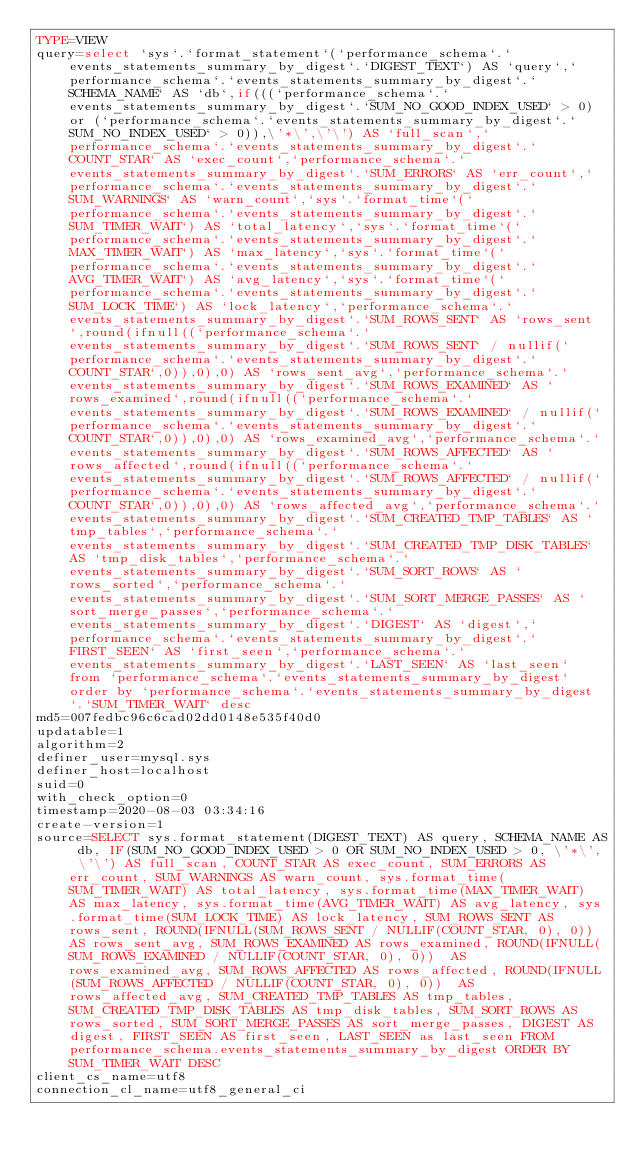<code> <loc_0><loc_0><loc_500><loc_500><_VisualBasic_>TYPE=VIEW
query=select `sys`.`format_statement`(`performance_schema`.`events_statements_summary_by_digest`.`DIGEST_TEXT`) AS `query`,`performance_schema`.`events_statements_summary_by_digest`.`SCHEMA_NAME` AS `db`,if(((`performance_schema`.`events_statements_summary_by_digest`.`SUM_NO_GOOD_INDEX_USED` > 0) or (`performance_schema`.`events_statements_summary_by_digest`.`SUM_NO_INDEX_USED` > 0)),\'*\',\'\') AS `full_scan`,`performance_schema`.`events_statements_summary_by_digest`.`COUNT_STAR` AS `exec_count`,`performance_schema`.`events_statements_summary_by_digest`.`SUM_ERRORS` AS `err_count`,`performance_schema`.`events_statements_summary_by_digest`.`SUM_WARNINGS` AS `warn_count`,`sys`.`format_time`(`performance_schema`.`events_statements_summary_by_digest`.`SUM_TIMER_WAIT`) AS `total_latency`,`sys`.`format_time`(`performance_schema`.`events_statements_summary_by_digest`.`MAX_TIMER_WAIT`) AS `max_latency`,`sys`.`format_time`(`performance_schema`.`events_statements_summary_by_digest`.`AVG_TIMER_WAIT`) AS `avg_latency`,`sys`.`format_time`(`performance_schema`.`events_statements_summary_by_digest`.`SUM_LOCK_TIME`) AS `lock_latency`,`performance_schema`.`events_statements_summary_by_digest`.`SUM_ROWS_SENT` AS `rows_sent`,round(ifnull((`performance_schema`.`events_statements_summary_by_digest`.`SUM_ROWS_SENT` / nullif(`performance_schema`.`events_statements_summary_by_digest`.`COUNT_STAR`,0)),0),0) AS `rows_sent_avg`,`performance_schema`.`events_statements_summary_by_digest`.`SUM_ROWS_EXAMINED` AS `rows_examined`,round(ifnull((`performance_schema`.`events_statements_summary_by_digest`.`SUM_ROWS_EXAMINED` / nullif(`performance_schema`.`events_statements_summary_by_digest`.`COUNT_STAR`,0)),0),0) AS `rows_examined_avg`,`performance_schema`.`events_statements_summary_by_digest`.`SUM_ROWS_AFFECTED` AS `rows_affected`,round(ifnull((`performance_schema`.`events_statements_summary_by_digest`.`SUM_ROWS_AFFECTED` / nullif(`performance_schema`.`events_statements_summary_by_digest`.`COUNT_STAR`,0)),0),0) AS `rows_affected_avg`,`performance_schema`.`events_statements_summary_by_digest`.`SUM_CREATED_TMP_TABLES` AS `tmp_tables`,`performance_schema`.`events_statements_summary_by_digest`.`SUM_CREATED_TMP_DISK_TABLES` AS `tmp_disk_tables`,`performance_schema`.`events_statements_summary_by_digest`.`SUM_SORT_ROWS` AS `rows_sorted`,`performance_schema`.`events_statements_summary_by_digest`.`SUM_SORT_MERGE_PASSES` AS `sort_merge_passes`,`performance_schema`.`events_statements_summary_by_digest`.`DIGEST` AS `digest`,`performance_schema`.`events_statements_summary_by_digest`.`FIRST_SEEN` AS `first_seen`,`performance_schema`.`events_statements_summary_by_digest`.`LAST_SEEN` AS `last_seen` from `performance_schema`.`events_statements_summary_by_digest` order by `performance_schema`.`events_statements_summary_by_digest`.`SUM_TIMER_WAIT` desc
md5=007fedbc96c6cad02dd0148e535f40d0
updatable=1
algorithm=2
definer_user=mysql.sys
definer_host=localhost
suid=0
with_check_option=0
timestamp=2020-08-03 03:34:16
create-version=1
source=SELECT sys.format_statement(DIGEST_TEXT) AS query, SCHEMA_NAME AS db, IF(SUM_NO_GOOD_INDEX_USED > 0 OR SUM_NO_INDEX_USED > 0, \'*\', \'\') AS full_scan, COUNT_STAR AS exec_count, SUM_ERRORS AS err_count, SUM_WARNINGS AS warn_count, sys.format_time(SUM_TIMER_WAIT) AS total_latency, sys.format_time(MAX_TIMER_WAIT) AS max_latency, sys.format_time(AVG_TIMER_WAIT) AS avg_latency, sys.format_time(SUM_LOCK_TIME) AS lock_latency, SUM_ROWS_SENT AS rows_sent, ROUND(IFNULL(SUM_ROWS_SENT / NULLIF(COUNT_STAR, 0), 0)) AS rows_sent_avg, SUM_ROWS_EXAMINED AS rows_examined, ROUND(IFNULL(SUM_ROWS_EXAMINED / NULLIF(COUNT_STAR, 0), 0))  AS rows_examined_avg, SUM_ROWS_AFFECTED AS rows_affected, ROUND(IFNULL(SUM_ROWS_AFFECTED / NULLIF(COUNT_STAR, 0), 0))  AS rows_affected_avg, SUM_CREATED_TMP_TABLES AS tmp_tables, SUM_CREATED_TMP_DISK_TABLES AS tmp_disk_tables, SUM_SORT_ROWS AS rows_sorted, SUM_SORT_MERGE_PASSES AS sort_merge_passes, DIGEST AS digest, FIRST_SEEN AS first_seen, LAST_SEEN as last_seen FROM performance_schema.events_statements_summary_by_digest ORDER BY SUM_TIMER_WAIT DESC
client_cs_name=utf8
connection_cl_name=utf8_general_ci</code> 